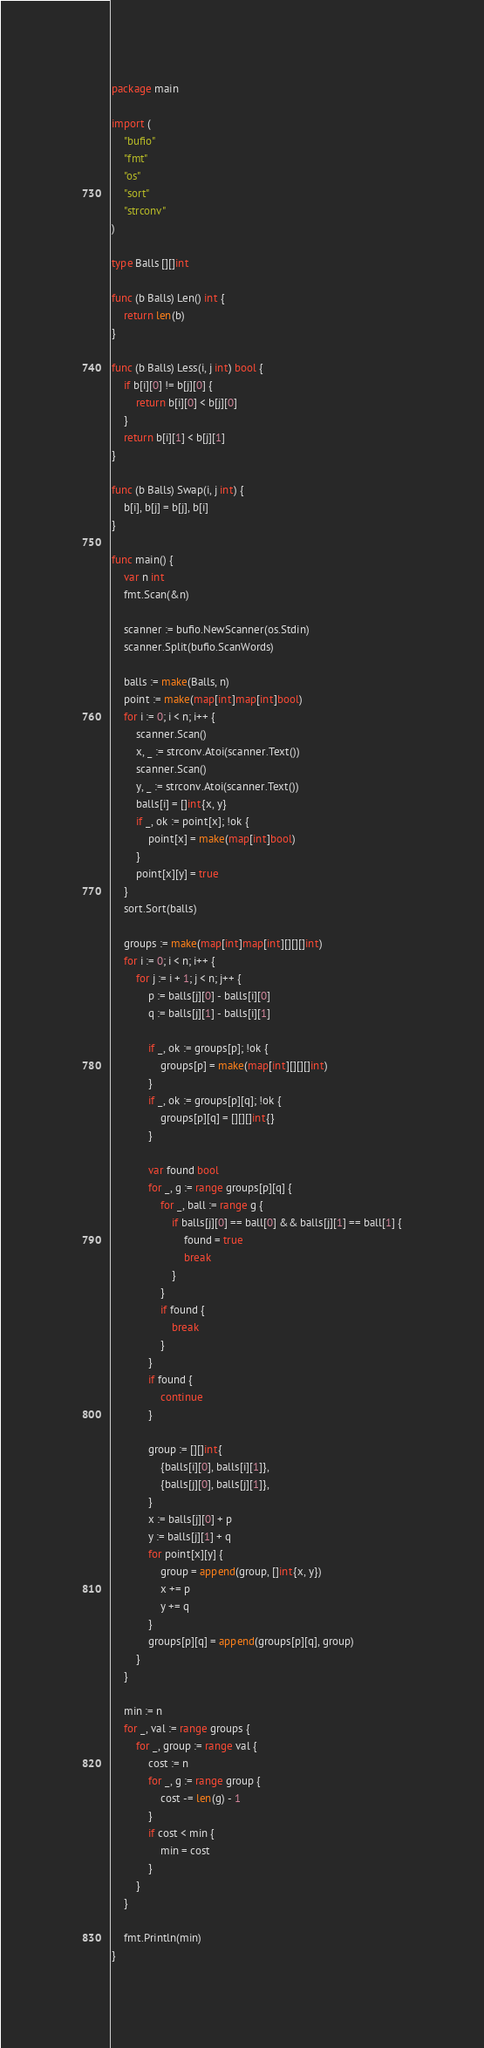Convert code to text. <code><loc_0><loc_0><loc_500><loc_500><_Go_>package main

import (
	"bufio"
	"fmt"
	"os"
	"sort"
	"strconv"
)

type Balls [][]int

func (b Balls) Len() int {
	return len(b)
}

func (b Balls) Less(i, j int) bool {
	if b[i][0] != b[j][0] {
		return b[i][0] < b[j][0]
	}
	return b[i][1] < b[j][1]
}

func (b Balls) Swap(i, j int) {
	b[i], b[j] = b[j], b[i]
}

func main() {
	var n int
	fmt.Scan(&n)

	scanner := bufio.NewScanner(os.Stdin)
	scanner.Split(bufio.ScanWords)

	balls := make(Balls, n)
	point := make(map[int]map[int]bool)
	for i := 0; i < n; i++ {
		scanner.Scan()
		x, _ := strconv.Atoi(scanner.Text())
		scanner.Scan()
		y, _ := strconv.Atoi(scanner.Text())
		balls[i] = []int{x, y}
		if _, ok := point[x]; !ok {
			point[x] = make(map[int]bool)
		}
		point[x][y] = true
	}
	sort.Sort(balls)

	groups := make(map[int]map[int][][][]int)
	for i := 0; i < n; i++ {
		for j := i + 1; j < n; j++ {
			p := balls[j][0] - balls[i][0]
			q := balls[j][1] - balls[i][1]

			if _, ok := groups[p]; !ok {
				groups[p] = make(map[int][][][]int)
			}
			if _, ok := groups[p][q]; !ok {
				groups[p][q] = [][][]int{}
			}

			var found bool
			for _, g := range groups[p][q] {
				for _, ball := range g {
					if balls[j][0] == ball[0] && balls[j][1] == ball[1] {
						found = true
						break
					}
				}
				if found {
					break
				}
			}
			if found {
				continue
			}

			group := [][]int{
				{balls[i][0], balls[i][1]},
				{balls[j][0], balls[j][1]},
			}
			x := balls[j][0] + p
			y := balls[j][1] + q
			for point[x][y] {
				group = append(group, []int{x, y})
				x += p
				y += q
			}
			groups[p][q] = append(groups[p][q], group)
		}
	}

	min := n
	for _, val := range groups {
		for _, group := range val {
			cost := n
			for _, g := range group {
				cost -= len(g) - 1
			}
			if cost < min {
				min = cost
			}
		}
	}

	fmt.Println(min)
}
</code> 